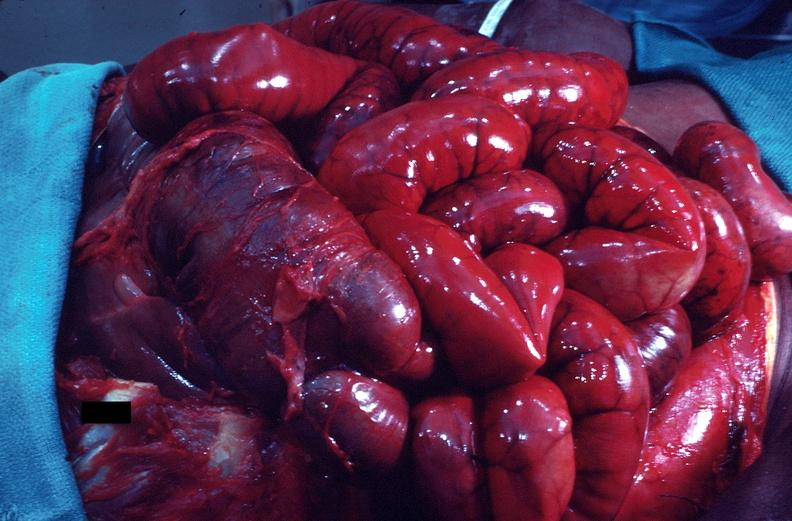what is present?
Answer the question using a single word or phrase. Gastrointestinal 